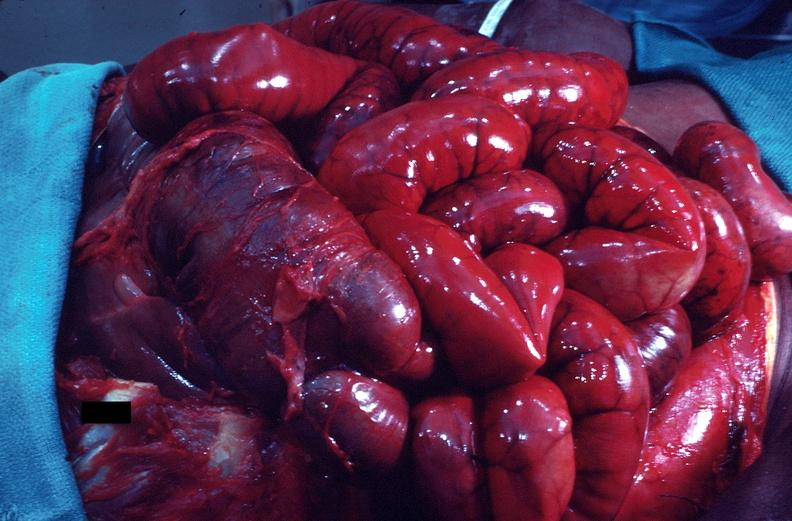what is present?
Answer the question using a single word or phrase. Gastrointestinal 